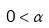<formula> <loc_0><loc_0><loc_500><loc_500>0 < \alpha</formula> 